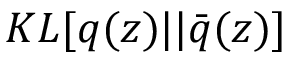<formula> <loc_0><loc_0><loc_500><loc_500>K L [ q ( z ) | | \bar { q } ( z ) ]</formula> 